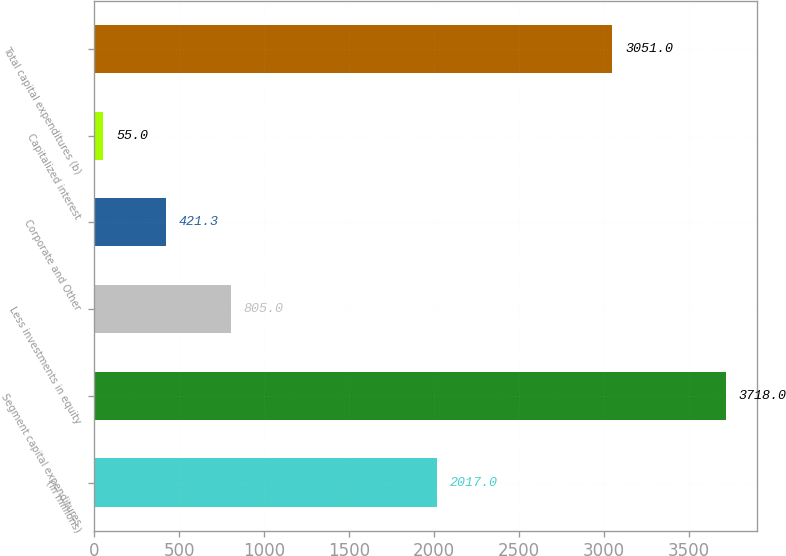Convert chart to OTSL. <chart><loc_0><loc_0><loc_500><loc_500><bar_chart><fcel>(In millions)<fcel>Segment capital expenditures<fcel>Less investments in equity<fcel>Corporate and Other<fcel>Capitalized interest<fcel>Total capital expenditures (b)<nl><fcel>2017<fcel>3718<fcel>805<fcel>421.3<fcel>55<fcel>3051<nl></chart> 